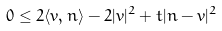<formula> <loc_0><loc_0><loc_500><loc_500>0 \leq 2 \langle v , n \rangle - 2 | v | ^ { 2 } + t | n - v | ^ { 2 }</formula> 